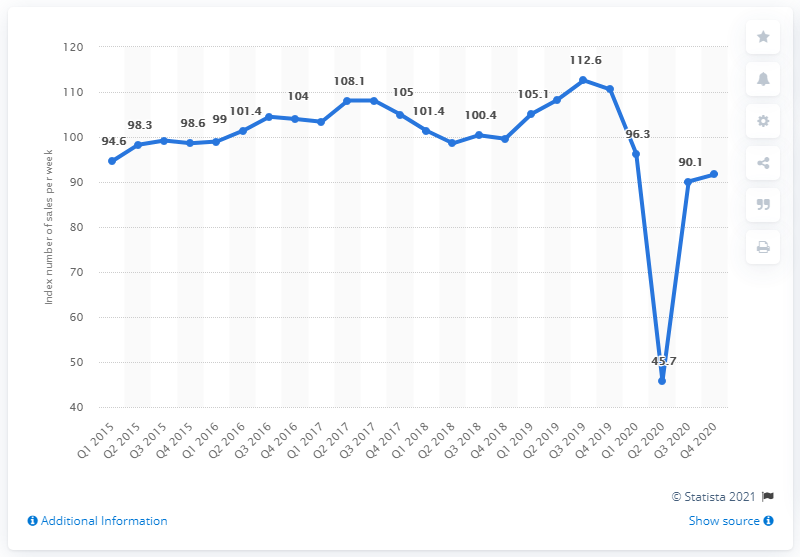Point out several critical features in this image. In the third quarter of 2019, the peak sales volume of footwear and leather goods was 112.6. 